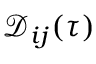<formula> <loc_0><loc_0><loc_500><loc_500>\mathcal { D } _ { i j } ( \tau )</formula> 